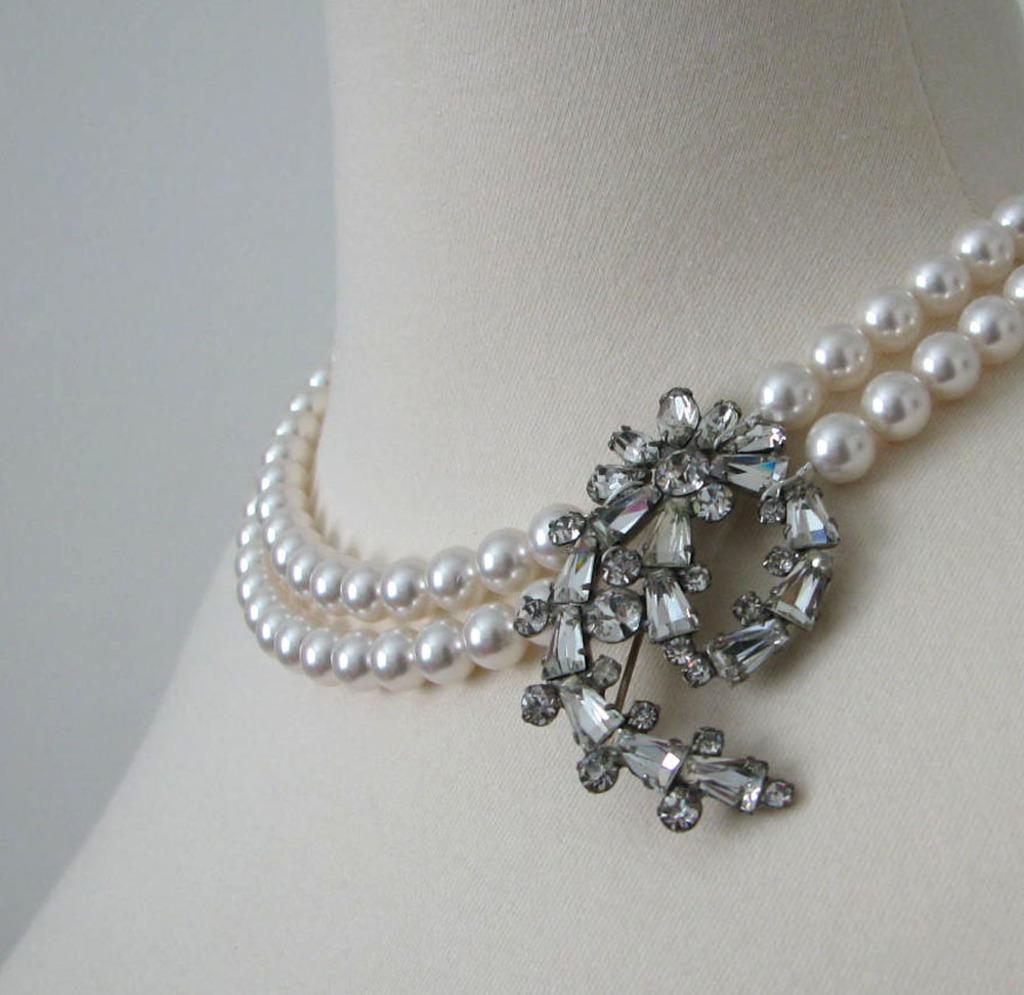What is the main subject of the picture? The main subject of the picture is an ornament. What is the color of the pendant in the ornament? The pendant in the ornament is black. What type of beads are present in the ornament? There are white pearls in the ornament. What color is the background of the ornament? The background of the ornament is white. How does the income of the person wearing the ornament affect the fog in the image? There is no person wearing the ornament in the image, and there is no fog present. 